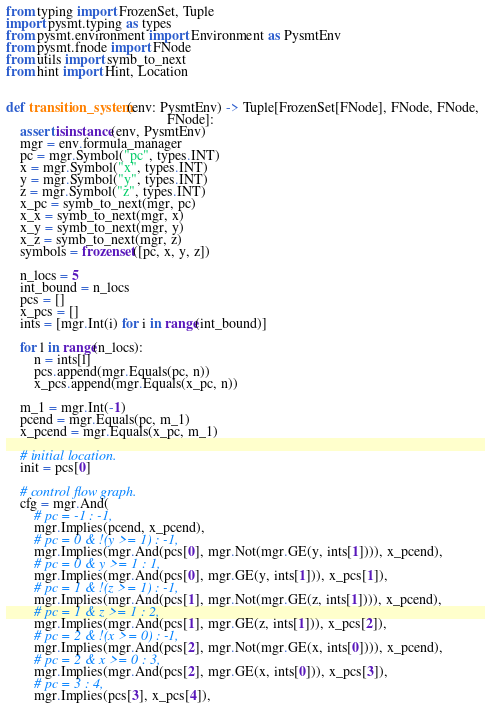<code> <loc_0><loc_0><loc_500><loc_500><_Python_>from typing import FrozenSet, Tuple
import pysmt.typing as types
from pysmt.environment import Environment as PysmtEnv
from pysmt.fnode import FNode
from utils import symb_to_next
from hint import Hint, Location


def transition_system(env: PysmtEnv) -> Tuple[FrozenSet[FNode], FNode, FNode,
                                              FNode]:
    assert isinstance(env, PysmtEnv)
    mgr = env.formula_manager
    pc = mgr.Symbol("pc", types.INT)
    x = mgr.Symbol("x", types.INT)
    y = mgr.Symbol("y", types.INT)
    z = mgr.Symbol("z", types.INT)
    x_pc = symb_to_next(mgr, pc)
    x_x = symb_to_next(mgr, x)
    x_y = symb_to_next(mgr, y)
    x_z = symb_to_next(mgr, z)
    symbols = frozenset([pc, x, y, z])

    n_locs = 5
    int_bound = n_locs
    pcs = []
    x_pcs = []
    ints = [mgr.Int(i) for i in range(int_bound)]

    for l in range(n_locs):
        n = ints[l]
        pcs.append(mgr.Equals(pc, n))
        x_pcs.append(mgr.Equals(x_pc, n))

    m_1 = mgr.Int(-1)
    pcend = mgr.Equals(pc, m_1)
    x_pcend = mgr.Equals(x_pc, m_1)

    # initial location.
    init = pcs[0]

    # control flow graph.
    cfg = mgr.And(
        # pc = -1 : -1,
        mgr.Implies(pcend, x_pcend),
        # pc = 0 & !(y >= 1) : -1,
        mgr.Implies(mgr.And(pcs[0], mgr.Not(mgr.GE(y, ints[1]))), x_pcend),
        # pc = 0 & y >= 1 : 1,
        mgr.Implies(mgr.And(pcs[0], mgr.GE(y, ints[1])), x_pcs[1]),
        # pc = 1 & !(z >= 1) : -1,
        mgr.Implies(mgr.And(pcs[1], mgr.Not(mgr.GE(z, ints[1]))), x_pcend),
        # pc = 1 & z >= 1 : 2,
        mgr.Implies(mgr.And(pcs[1], mgr.GE(z, ints[1])), x_pcs[2]),
        # pc = 2 & !(x >= 0) : -1,
        mgr.Implies(mgr.And(pcs[2], mgr.Not(mgr.GE(x, ints[0]))), x_pcend),
        # pc = 2 & x >= 0 : 3,
        mgr.Implies(mgr.And(pcs[2], mgr.GE(x, ints[0])), x_pcs[3]),
        # pc = 3 : 4,
        mgr.Implies(pcs[3], x_pcs[4]),</code> 